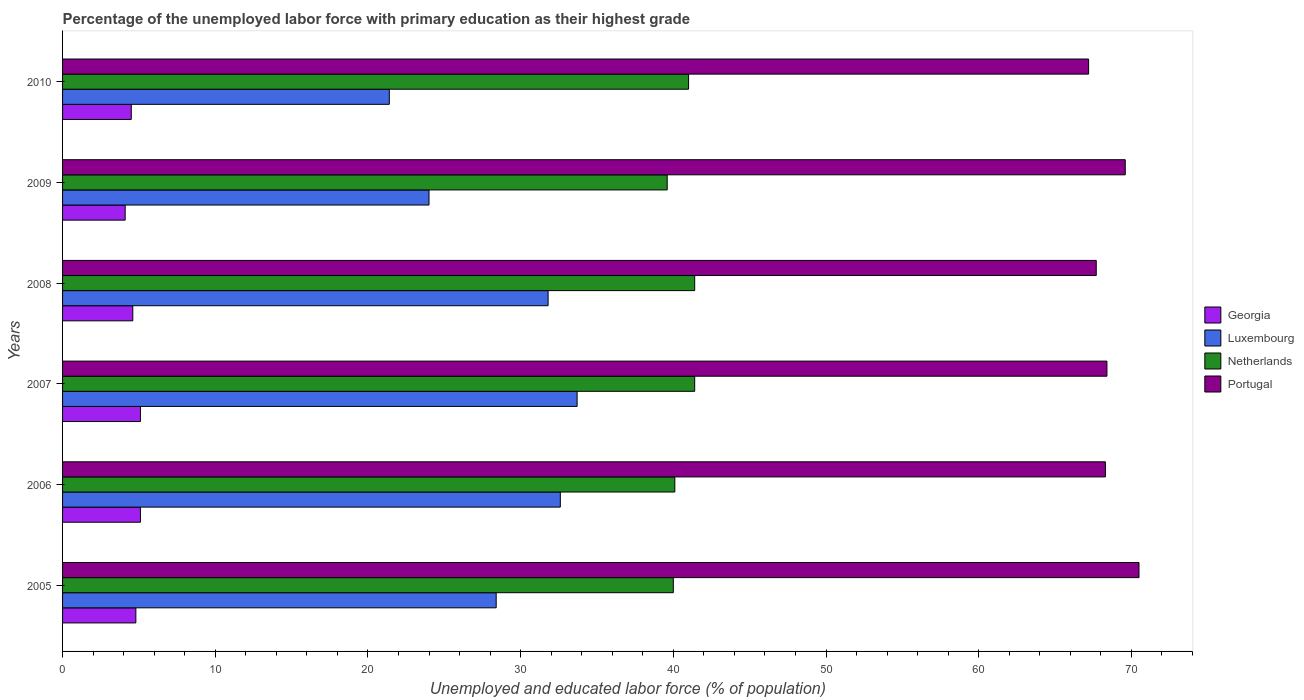Are the number of bars per tick equal to the number of legend labels?
Ensure brevity in your answer.  Yes. In how many cases, is the number of bars for a given year not equal to the number of legend labels?
Ensure brevity in your answer.  0. What is the percentage of the unemployed labor force with primary education in Georgia in 2008?
Your response must be concise. 4.6. Across all years, what is the maximum percentage of the unemployed labor force with primary education in Georgia?
Keep it short and to the point. 5.1. Across all years, what is the minimum percentage of the unemployed labor force with primary education in Portugal?
Your response must be concise. 67.2. In which year was the percentage of the unemployed labor force with primary education in Georgia minimum?
Keep it short and to the point. 2009. What is the total percentage of the unemployed labor force with primary education in Netherlands in the graph?
Offer a very short reply. 243.5. What is the difference between the percentage of the unemployed labor force with primary education in Georgia in 2006 and that in 2010?
Offer a very short reply. 0.6. What is the difference between the percentage of the unemployed labor force with primary education in Luxembourg in 2005 and the percentage of the unemployed labor force with primary education in Netherlands in 2007?
Offer a very short reply. -13. What is the average percentage of the unemployed labor force with primary education in Portugal per year?
Make the answer very short. 68.62. In the year 2005, what is the difference between the percentage of the unemployed labor force with primary education in Luxembourg and percentage of the unemployed labor force with primary education in Netherlands?
Your response must be concise. -11.6. In how many years, is the percentage of the unemployed labor force with primary education in Georgia greater than 48 %?
Provide a short and direct response. 0. What is the ratio of the percentage of the unemployed labor force with primary education in Netherlands in 2006 to that in 2007?
Your answer should be very brief. 0.97. Is the percentage of the unemployed labor force with primary education in Georgia in 2006 less than that in 2009?
Your response must be concise. No. What is the difference between the highest and the second highest percentage of the unemployed labor force with primary education in Luxembourg?
Your response must be concise. 1.1. What is the difference between the highest and the lowest percentage of the unemployed labor force with primary education in Portugal?
Ensure brevity in your answer.  3.3. In how many years, is the percentage of the unemployed labor force with primary education in Portugal greater than the average percentage of the unemployed labor force with primary education in Portugal taken over all years?
Keep it short and to the point. 2. Is the sum of the percentage of the unemployed labor force with primary education in Luxembourg in 2006 and 2009 greater than the maximum percentage of the unemployed labor force with primary education in Netherlands across all years?
Offer a very short reply. Yes. What does the 4th bar from the top in 2009 represents?
Offer a very short reply. Georgia. What does the 3rd bar from the bottom in 2009 represents?
Keep it short and to the point. Netherlands. Is it the case that in every year, the sum of the percentage of the unemployed labor force with primary education in Luxembourg and percentage of the unemployed labor force with primary education in Portugal is greater than the percentage of the unemployed labor force with primary education in Georgia?
Make the answer very short. Yes. How many bars are there?
Keep it short and to the point. 24. How many years are there in the graph?
Give a very brief answer. 6. What is the difference between two consecutive major ticks on the X-axis?
Provide a short and direct response. 10. Are the values on the major ticks of X-axis written in scientific E-notation?
Offer a very short reply. No. Does the graph contain any zero values?
Give a very brief answer. No. Where does the legend appear in the graph?
Make the answer very short. Center right. How many legend labels are there?
Your answer should be very brief. 4. How are the legend labels stacked?
Your answer should be compact. Vertical. What is the title of the graph?
Offer a very short reply. Percentage of the unemployed labor force with primary education as their highest grade. What is the label or title of the X-axis?
Provide a succinct answer. Unemployed and educated labor force (% of population). What is the label or title of the Y-axis?
Ensure brevity in your answer.  Years. What is the Unemployed and educated labor force (% of population) in Georgia in 2005?
Offer a very short reply. 4.8. What is the Unemployed and educated labor force (% of population) of Luxembourg in 2005?
Make the answer very short. 28.4. What is the Unemployed and educated labor force (% of population) of Netherlands in 2005?
Ensure brevity in your answer.  40. What is the Unemployed and educated labor force (% of population) of Portugal in 2005?
Ensure brevity in your answer.  70.5. What is the Unemployed and educated labor force (% of population) of Georgia in 2006?
Your answer should be compact. 5.1. What is the Unemployed and educated labor force (% of population) of Luxembourg in 2006?
Provide a short and direct response. 32.6. What is the Unemployed and educated labor force (% of population) of Netherlands in 2006?
Offer a very short reply. 40.1. What is the Unemployed and educated labor force (% of population) of Portugal in 2006?
Keep it short and to the point. 68.3. What is the Unemployed and educated labor force (% of population) in Georgia in 2007?
Provide a succinct answer. 5.1. What is the Unemployed and educated labor force (% of population) of Luxembourg in 2007?
Your response must be concise. 33.7. What is the Unemployed and educated labor force (% of population) of Netherlands in 2007?
Provide a succinct answer. 41.4. What is the Unemployed and educated labor force (% of population) in Portugal in 2007?
Make the answer very short. 68.4. What is the Unemployed and educated labor force (% of population) of Georgia in 2008?
Your answer should be compact. 4.6. What is the Unemployed and educated labor force (% of population) of Luxembourg in 2008?
Give a very brief answer. 31.8. What is the Unemployed and educated labor force (% of population) of Netherlands in 2008?
Provide a short and direct response. 41.4. What is the Unemployed and educated labor force (% of population) in Portugal in 2008?
Your answer should be compact. 67.7. What is the Unemployed and educated labor force (% of population) in Georgia in 2009?
Ensure brevity in your answer.  4.1. What is the Unemployed and educated labor force (% of population) of Luxembourg in 2009?
Provide a short and direct response. 24. What is the Unemployed and educated labor force (% of population) of Netherlands in 2009?
Offer a very short reply. 39.6. What is the Unemployed and educated labor force (% of population) in Portugal in 2009?
Provide a succinct answer. 69.6. What is the Unemployed and educated labor force (% of population) in Luxembourg in 2010?
Keep it short and to the point. 21.4. What is the Unemployed and educated labor force (% of population) of Portugal in 2010?
Provide a succinct answer. 67.2. Across all years, what is the maximum Unemployed and educated labor force (% of population) in Georgia?
Keep it short and to the point. 5.1. Across all years, what is the maximum Unemployed and educated labor force (% of population) in Luxembourg?
Offer a terse response. 33.7. Across all years, what is the maximum Unemployed and educated labor force (% of population) of Netherlands?
Provide a succinct answer. 41.4. Across all years, what is the maximum Unemployed and educated labor force (% of population) of Portugal?
Offer a very short reply. 70.5. Across all years, what is the minimum Unemployed and educated labor force (% of population) of Georgia?
Your response must be concise. 4.1. Across all years, what is the minimum Unemployed and educated labor force (% of population) of Luxembourg?
Ensure brevity in your answer.  21.4. Across all years, what is the minimum Unemployed and educated labor force (% of population) in Netherlands?
Provide a short and direct response. 39.6. Across all years, what is the minimum Unemployed and educated labor force (% of population) of Portugal?
Give a very brief answer. 67.2. What is the total Unemployed and educated labor force (% of population) in Georgia in the graph?
Your response must be concise. 28.2. What is the total Unemployed and educated labor force (% of population) of Luxembourg in the graph?
Provide a succinct answer. 171.9. What is the total Unemployed and educated labor force (% of population) in Netherlands in the graph?
Give a very brief answer. 243.5. What is the total Unemployed and educated labor force (% of population) of Portugal in the graph?
Provide a succinct answer. 411.7. What is the difference between the Unemployed and educated labor force (% of population) in Netherlands in 2005 and that in 2006?
Your answer should be compact. -0.1. What is the difference between the Unemployed and educated labor force (% of population) of Georgia in 2005 and that in 2007?
Your response must be concise. -0.3. What is the difference between the Unemployed and educated labor force (% of population) in Luxembourg in 2005 and that in 2007?
Keep it short and to the point. -5.3. What is the difference between the Unemployed and educated labor force (% of population) of Netherlands in 2005 and that in 2007?
Make the answer very short. -1.4. What is the difference between the Unemployed and educated labor force (% of population) of Netherlands in 2005 and that in 2008?
Make the answer very short. -1.4. What is the difference between the Unemployed and educated labor force (% of population) of Portugal in 2005 and that in 2008?
Your answer should be very brief. 2.8. What is the difference between the Unemployed and educated labor force (% of population) in Georgia in 2005 and that in 2009?
Keep it short and to the point. 0.7. What is the difference between the Unemployed and educated labor force (% of population) of Georgia in 2005 and that in 2010?
Provide a short and direct response. 0.3. What is the difference between the Unemployed and educated labor force (% of population) in Netherlands in 2005 and that in 2010?
Give a very brief answer. -1. What is the difference between the Unemployed and educated labor force (% of population) of Portugal in 2005 and that in 2010?
Your answer should be compact. 3.3. What is the difference between the Unemployed and educated labor force (% of population) of Netherlands in 2006 and that in 2007?
Your answer should be very brief. -1.3. What is the difference between the Unemployed and educated labor force (% of population) in Portugal in 2006 and that in 2007?
Ensure brevity in your answer.  -0.1. What is the difference between the Unemployed and educated labor force (% of population) in Georgia in 2006 and that in 2008?
Your answer should be compact. 0.5. What is the difference between the Unemployed and educated labor force (% of population) in Luxembourg in 2006 and that in 2008?
Provide a succinct answer. 0.8. What is the difference between the Unemployed and educated labor force (% of population) in Netherlands in 2006 and that in 2008?
Provide a succinct answer. -1.3. What is the difference between the Unemployed and educated labor force (% of population) of Portugal in 2006 and that in 2008?
Provide a succinct answer. 0.6. What is the difference between the Unemployed and educated labor force (% of population) in Luxembourg in 2006 and that in 2009?
Give a very brief answer. 8.6. What is the difference between the Unemployed and educated labor force (% of population) in Portugal in 2006 and that in 2009?
Provide a short and direct response. -1.3. What is the difference between the Unemployed and educated labor force (% of population) in Georgia in 2006 and that in 2010?
Give a very brief answer. 0.6. What is the difference between the Unemployed and educated labor force (% of population) of Luxembourg in 2006 and that in 2010?
Your response must be concise. 11.2. What is the difference between the Unemployed and educated labor force (% of population) in Netherlands in 2006 and that in 2010?
Provide a succinct answer. -0.9. What is the difference between the Unemployed and educated labor force (% of population) in Portugal in 2006 and that in 2010?
Make the answer very short. 1.1. What is the difference between the Unemployed and educated labor force (% of population) of Georgia in 2007 and that in 2008?
Provide a succinct answer. 0.5. What is the difference between the Unemployed and educated labor force (% of population) of Luxembourg in 2007 and that in 2008?
Offer a very short reply. 1.9. What is the difference between the Unemployed and educated labor force (% of population) in Portugal in 2007 and that in 2008?
Your answer should be very brief. 0.7. What is the difference between the Unemployed and educated labor force (% of population) in Georgia in 2007 and that in 2009?
Your answer should be very brief. 1. What is the difference between the Unemployed and educated labor force (% of population) in Luxembourg in 2007 and that in 2009?
Make the answer very short. 9.7. What is the difference between the Unemployed and educated labor force (% of population) in Netherlands in 2007 and that in 2009?
Make the answer very short. 1.8. What is the difference between the Unemployed and educated labor force (% of population) of Portugal in 2007 and that in 2009?
Provide a short and direct response. -1.2. What is the difference between the Unemployed and educated labor force (% of population) of Georgia in 2007 and that in 2010?
Your answer should be compact. 0.6. What is the difference between the Unemployed and educated labor force (% of population) of Georgia in 2008 and that in 2009?
Ensure brevity in your answer.  0.5. What is the difference between the Unemployed and educated labor force (% of population) in Netherlands in 2008 and that in 2009?
Your response must be concise. 1.8. What is the difference between the Unemployed and educated labor force (% of population) in Portugal in 2008 and that in 2009?
Offer a terse response. -1.9. What is the difference between the Unemployed and educated labor force (% of population) in Luxembourg in 2008 and that in 2010?
Make the answer very short. 10.4. What is the difference between the Unemployed and educated labor force (% of population) in Netherlands in 2008 and that in 2010?
Make the answer very short. 0.4. What is the difference between the Unemployed and educated labor force (% of population) of Georgia in 2009 and that in 2010?
Offer a very short reply. -0.4. What is the difference between the Unemployed and educated labor force (% of population) in Luxembourg in 2009 and that in 2010?
Make the answer very short. 2.6. What is the difference between the Unemployed and educated labor force (% of population) in Georgia in 2005 and the Unemployed and educated labor force (% of population) in Luxembourg in 2006?
Your answer should be compact. -27.8. What is the difference between the Unemployed and educated labor force (% of population) of Georgia in 2005 and the Unemployed and educated labor force (% of population) of Netherlands in 2006?
Ensure brevity in your answer.  -35.3. What is the difference between the Unemployed and educated labor force (% of population) in Georgia in 2005 and the Unemployed and educated labor force (% of population) in Portugal in 2006?
Keep it short and to the point. -63.5. What is the difference between the Unemployed and educated labor force (% of population) in Luxembourg in 2005 and the Unemployed and educated labor force (% of population) in Portugal in 2006?
Provide a succinct answer. -39.9. What is the difference between the Unemployed and educated labor force (% of population) of Netherlands in 2005 and the Unemployed and educated labor force (% of population) of Portugal in 2006?
Provide a short and direct response. -28.3. What is the difference between the Unemployed and educated labor force (% of population) in Georgia in 2005 and the Unemployed and educated labor force (% of population) in Luxembourg in 2007?
Ensure brevity in your answer.  -28.9. What is the difference between the Unemployed and educated labor force (% of population) of Georgia in 2005 and the Unemployed and educated labor force (% of population) of Netherlands in 2007?
Your response must be concise. -36.6. What is the difference between the Unemployed and educated labor force (% of population) of Georgia in 2005 and the Unemployed and educated labor force (% of population) of Portugal in 2007?
Keep it short and to the point. -63.6. What is the difference between the Unemployed and educated labor force (% of population) in Luxembourg in 2005 and the Unemployed and educated labor force (% of population) in Netherlands in 2007?
Provide a succinct answer. -13. What is the difference between the Unemployed and educated labor force (% of population) of Netherlands in 2005 and the Unemployed and educated labor force (% of population) of Portugal in 2007?
Make the answer very short. -28.4. What is the difference between the Unemployed and educated labor force (% of population) of Georgia in 2005 and the Unemployed and educated labor force (% of population) of Luxembourg in 2008?
Ensure brevity in your answer.  -27. What is the difference between the Unemployed and educated labor force (% of population) in Georgia in 2005 and the Unemployed and educated labor force (% of population) in Netherlands in 2008?
Provide a short and direct response. -36.6. What is the difference between the Unemployed and educated labor force (% of population) of Georgia in 2005 and the Unemployed and educated labor force (% of population) of Portugal in 2008?
Offer a terse response. -62.9. What is the difference between the Unemployed and educated labor force (% of population) in Luxembourg in 2005 and the Unemployed and educated labor force (% of population) in Netherlands in 2008?
Give a very brief answer. -13. What is the difference between the Unemployed and educated labor force (% of population) of Luxembourg in 2005 and the Unemployed and educated labor force (% of population) of Portugal in 2008?
Make the answer very short. -39.3. What is the difference between the Unemployed and educated labor force (% of population) of Netherlands in 2005 and the Unemployed and educated labor force (% of population) of Portugal in 2008?
Your response must be concise. -27.7. What is the difference between the Unemployed and educated labor force (% of population) of Georgia in 2005 and the Unemployed and educated labor force (% of population) of Luxembourg in 2009?
Keep it short and to the point. -19.2. What is the difference between the Unemployed and educated labor force (% of population) in Georgia in 2005 and the Unemployed and educated labor force (% of population) in Netherlands in 2009?
Give a very brief answer. -34.8. What is the difference between the Unemployed and educated labor force (% of population) of Georgia in 2005 and the Unemployed and educated labor force (% of population) of Portugal in 2009?
Provide a short and direct response. -64.8. What is the difference between the Unemployed and educated labor force (% of population) of Luxembourg in 2005 and the Unemployed and educated labor force (% of population) of Netherlands in 2009?
Offer a very short reply. -11.2. What is the difference between the Unemployed and educated labor force (% of population) in Luxembourg in 2005 and the Unemployed and educated labor force (% of population) in Portugal in 2009?
Provide a short and direct response. -41.2. What is the difference between the Unemployed and educated labor force (% of population) of Netherlands in 2005 and the Unemployed and educated labor force (% of population) of Portugal in 2009?
Offer a very short reply. -29.6. What is the difference between the Unemployed and educated labor force (% of population) in Georgia in 2005 and the Unemployed and educated labor force (% of population) in Luxembourg in 2010?
Your response must be concise. -16.6. What is the difference between the Unemployed and educated labor force (% of population) in Georgia in 2005 and the Unemployed and educated labor force (% of population) in Netherlands in 2010?
Provide a succinct answer. -36.2. What is the difference between the Unemployed and educated labor force (% of population) in Georgia in 2005 and the Unemployed and educated labor force (% of population) in Portugal in 2010?
Offer a very short reply. -62.4. What is the difference between the Unemployed and educated labor force (% of population) of Luxembourg in 2005 and the Unemployed and educated labor force (% of population) of Netherlands in 2010?
Offer a very short reply. -12.6. What is the difference between the Unemployed and educated labor force (% of population) in Luxembourg in 2005 and the Unemployed and educated labor force (% of population) in Portugal in 2010?
Provide a succinct answer. -38.8. What is the difference between the Unemployed and educated labor force (% of population) in Netherlands in 2005 and the Unemployed and educated labor force (% of population) in Portugal in 2010?
Offer a very short reply. -27.2. What is the difference between the Unemployed and educated labor force (% of population) of Georgia in 2006 and the Unemployed and educated labor force (% of population) of Luxembourg in 2007?
Keep it short and to the point. -28.6. What is the difference between the Unemployed and educated labor force (% of population) in Georgia in 2006 and the Unemployed and educated labor force (% of population) in Netherlands in 2007?
Give a very brief answer. -36.3. What is the difference between the Unemployed and educated labor force (% of population) of Georgia in 2006 and the Unemployed and educated labor force (% of population) of Portugal in 2007?
Your answer should be compact. -63.3. What is the difference between the Unemployed and educated labor force (% of population) of Luxembourg in 2006 and the Unemployed and educated labor force (% of population) of Portugal in 2007?
Offer a terse response. -35.8. What is the difference between the Unemployed and educated labor force (% of population) of Netherlands in 2006 and the Unemployed and educated labor force (% of population) of Portugal in 2007?
Offer a terse response. -28.3. What is the difference between the Unemployed and educated labor force (% of population) in Georgia in 2006 and the Unemployed and educated labor force (% of population) in Luxembourg in 2008?
Offer a terse response. -26.7. What is the difference between the Unemployed and educated labor force (% of population) of Georgia in 2006 and the Unemployed and educated labor force (% of population) of Netherlands in 2008?
Make the answer very short. -36.3. What is the difference between the Unemployed and educated labor force (% of population) in Georgia in 2006 and the Unemployed and educated labor force (% of population) in Portugal in 2008?
Provide a short and direct response. -62.6. What is the difference between the Unemployed and educated labor force (% of population) of Luxembourg in 2006 and the Unemployed and educated labor force (% of population) of Netherlands in 2008?
Your response must be concise. -8.8. What is the difference between the Unemployed and educated labor force (% of population) in Luxembourg in 2006 and the Unemployed and educated labor force (% of population) in Portugal in 2008?
Your answer should be compact. -35.1. What is the difference between the Unemployed and educated labor force (% of population) in Netherlands in 2006 and the Unemployed and educated labor force (% of population) in Portugal in 2008?
Provide a succinct answer. -27.6. What is the difference between the Unemployed and educated labor force (% of population) of Georgia in 2006 and the Unemployed and educated labor force (% of population) of Luxembourg in 2009?
Your answer should be compact. -18.9. What is the difference between the Unemployed and educated labor force (% of population) in Georgia in 2006 and the Unemployed and educated labor force (% of population) in Netherlands in 2009?
Offer a terse response. -34.5. What is the difference between the Unemployed and educated labor force (% of population) in Georgia in 2006 and the Unemployed and educated labor force (% of population) in Portugal in 2009?
Provide a short and direct response. -64.5. What is the difference between the Unemployed and educated labor force (% of population) in Luxembourg in 2006 and the Unemployed and educated labor force (% of population) in Portugal in 2009?
Your response must be concise. -37. What is the difference between the Unemployed and educated labor force (% of population) of Netherlands in 2006 and the Unemployed and educated labor force (% of population) of Portugal in 2009?
Make the answer very short. -29.5. What is the difference between the Unemployed and educated labor force (% of population) in Georgia in 2006 and the Unemployed and educated labor force (% of population) in Luxembourg in 2010?
Make the answer very short. -16.3. What is the difference between the Unemployed and educated labor force (% of population) in Georgia in 2006 and the Unemployed and educated labor force (% of population) in Netherlands in 2010?
Make the answer very short. -35.9. What is the difference between the Unemployed and educated labor force (% of population) of Georgia in 2006 and the Unemployed and educated labor force (% of population) of Portugal in 2010?
Ensure brevity in your answer.  -62.1. What is the difference between the Unemployed and educated labor force (% of population) of Luxembourg in 2006 and the Unemployed and educated labor force (% of population) of Netherlands in 2010?
Keep it short and to the point. -8.4. What is the difference between the Unemployed and educated labor force (% of population) in Luxembourg in 2006 and the Unemployed and educated labor force (% of population) in Portugal in 2010?
Offer a terse response. -34.6. What is the difference between the Unemployed and educated labor force (% of population) in Netherlands in 2006 and the Unemployed and educated labor force (% of population) in Portugal in 2010?
Make the answer very short. -27.1. What is the difference between the Unemployed and educated labor force (% of population) of Georgia in 2007 and the Unemployed and educated labor force (% of population) of Luxembourg in 2008?
Ensure brevity in your answer.  -26.7. What is the difference between the Unemployed and educated labor force (% of population) of Georgia in 2007 and the Unemployed and educated labor force (% of population) of Netherlands in 2008?
Provide a short and direct response. -36.3. What is the difference between the Unemployed and educated labor force (% of population) in Georgia in 2007 and the Unemployed and educated labor force (% of population) in Portugal in 2008?
Your answer should be compact. -62.6. What is the difference between the Unemployed and educated labor force (% of population) of Luxembourg in 2007 and the Unemployed and educated labor force (% of population) of Portugal in 2008?
Give a very brief answer. -34. What is the difference between the Unemployed and educated labor force (% of population) of Netherlands in 2007 and the Unemployed and educated labor force (% of population) of Portugal in 2008?
Your answer should be compact. -26.3. What is the difference between the Unemployed and educated labor force (% of population) in Georgia in 2007 and the Unemployed and educated labor force (% of population) in Luxembourg in 2009?
Your response must be concise. -18.9. What is the difference between the Unemployed and educated labor force (% of population) in Georgia in 2007 and the Unemployed and educated labor force (% of population) in Netherlands in 2009?
Give a very brief answer. -34.5. What is the difference between the Unemployed and educated labor force (% of population) in Georgia in 2007 and the Unemployed and educated labor force (% of population) in Portugal in 2009?
Provide a short and direct response. -64.5. What is the difference between the Unemployed and educated labor force (% of population) of Luxembourg in 2007 and the Unemployed and educated labor force (% of population) of Netherlands in 2009?
Your response must be concise. -5.9. What is the difference between the Unemployed and educated labor force (% of population) of Luxembourg in 2007 and the Unemployed and educated labor force (% of population) of Portugal in 2009?
Keep it short and to the point. -35.9. What is the difference between the Unemployed and educated labor force (% of population) in Netherlands in 2007 and the Unemployed and educated labor force (% of population) in Portugal in 2009?
Give a very brief answer. -28.2. What is the difference between the Unemployed and educated labor force (% of population) of Georgia in 2007 and the Unemployed and educated labor force (% of population) of Luxembourg in 2010?
Offer a very short reply. -16.3. What is the difference between the Unemployed and educated labor force (% of population) in Georgia in 2007 and the Unemployed and educated labor force (% of population) in Netherlands in 2010?
Give a very brief answer. -35.9. What is the difference between the Unemployed and educated labor force (% of population) in Georgia in 2007 and the Unemployed and educated labor force (% of population) in Portugal in 2010?
Your response must be concise. -62.1. What is the difference between the Unemployed and educated labor force (% of population) of Luxembourg in 2007 and the Unemployed and educated labor force (% of population) of Portugal in 2010?
Ensure brevity in your answer.  -33.5. What is the difference between the Unemployed and educated labor force (% of population) of Netherlands in 2007 and the Unemployed and educated labor force (% of population) of Portugal in 2010?
Offer a very short reply. -25.8. What is the difference between the Unemployed and educated labor force (% of population) in Georgia in 2008 and the Unemployed and educated labor force (% of population) in Luxembourg in 2009?
Ensure brevity in your answer.  -19.4. What is the difference between the Unemployed and educated labor force (% of population) of Georgia in 2008 and the Unemployed and educated labor force (% of population) of Netherlands in 2009?
Make the answer very short. -35. What is the difference between the Unemployed and educated labor force (% of population) of Georgia in 2008 and the Unemployed and educated labor force (% of population) of Portugal in 2009?
Make the answer very short. -65. What is the difference between the Unemployed and educated labor force (% of population) of Luxembourg in 2008 and the Unemployed and educated labor force (% of population) of Netherlands in 2009?
Make the answer very short. -7.8. What is the difference between the Unemployed and educated labor force (% of population) in Luxembourg in 2008 and the Unemployed and educated labor force (% of population) in Portugal in 2009?
Ensure brevity in your answer.  -37.8. What is the difference between the Unemployed and educated labor force (% of population) of Netherlands in 2008 and the Unemployed and educated labor force (% of population) of Portugal in 2009?
Your response must be concise. -28.2. What is the difference between the Unemployed and educated labor force (% of population) of Georgia in 2008 and the Unemployed and educated labor force (% of population) of Luxembourg in 2010?
Give a very brief answer. -16.8. What is the difference between the Unemployed and educated labor force (% of population) of Georgia in 2008 and the Unemployed and educated labor force (% of population) of Netherlands in 2010?
Provide a succinct answer. -36.4. What is the difference between the Unemployed and educated labor force (% of population) of Georgia in 2008 and the Unemployed and educated labor force (% of population) of Portugal in 2010?
Offer a very short reply. -62.6. What is the difference between the Unemployed and educated labor force (% of population) in Luxembourg in 2008 and the Unemployed and educated labor force (% of population) in Netherlands in 2010?
Offer a very short reply. -9.2. What is the difference between the Unemployed and educated labor force (% of population) of Luxembourg in 2008 and the Unemployed and educated labor force (% of population) of Portugal in 2010?
Provide a succinct answer. -35.4. What is the difference between the Unemployed and educated labor force (% of population) of Netherlands in 2008 and the Unemployed and educated labor force (% of population) of Portugal in 2010?
Your answer should be very brief. -25.8. What is the difference between the Unemployed and educated labor force (% of population) of Georgia in 2009 and the Unemployed and educated labor force (% of population) of Luxembourg in 2010?
Your answer should be compact. -17.3. What is the difference between the Unemployed and educated labor force (% of population) of Georgia in 2009 and the Unemployed and educated labor force (% of population) of Netherlands in 2010?
Make the answer very short. -36.9. What is the difference between the Unemployed and educated labor force (% of population) in Georgia in 2009 and the Unemployed and educated labor force (% of population) in Portugal in 2010?
Keep it short and to the point. -63.1. What is the difference between the Unemployed and educated labor force (% of population) of Luxembourg in 2009 and the Unemployed and educated labor force (% of population) of Netherlands in 2010?
Make the answer very short. -17. What is the difference between the Unemployed and educated labor force (% of population) of Luxembourg in 2009 and the Unemployed and educated labor force (% of population) of Portugal in 2010?
Provide a succinct answer. -43.2. What is the difference between the Unemployed and educated labor force (% of population) of Netherlands in 2009 and the Unemployed and educated labor force (% of population) of Portugal in 2010?
Your answer should be compact. -27.6. What is the average Unemployed and educated labor force (% of population) of Georgia per year?
Keep it short and to the point. 4.7. What is the average Unemployed and educated labor force (% of population) of Luxembourg per year?
Your response must be concise. 28.65. What is the average Unemployed and educated labor force (% of population) of Netherlands per year?
Offer a terse response. 40.58. What is the average Unemployed and educated labor force (% of population) of Portugal per year?
Give a very brief answer. 68.62. In the year 2005, what is the difference between the Unemployed and educated labor force (% of population) in Georgia and Unemployed and educated labor force (% of population) in Luxembourg?
Your answer should be compact. -23.6. In the year 2005, what is the difference between the Unemployed and educated labor force (% of population) of Georgia and Unemployed and educated labor force (% of population) of Netherlands?
Ensure brevity in your answer.  -35.2. In the year 2005, what is the difference between the Unemployed and educated labor force (% of population) in Georgia and Unemployed and educated labor force (% of population) in Portugal?
Offer a very short reply. -65.7. In the year 2005, what is the difference between the Unemployed and educated labor force (% of population) in Luxembourg and Unemployed and educated labor force (% of population) in Portugal?
Your answer should be very brief. -42.1. In the year 2005, what is the difference between the Unemployed and educated labor force (% of population) of Netherlands and Unemployed and educated labor force (% of population) of Portugal?
Provide a short and direct response. -30.5. In the year 2006, what is the difference between the Unemployed and educated labor force (% of population) in Georgia and Unemployed and educated labor force (% of population) in Luxembourg?
Offer a terse response. -27.5. In the year 2006, what is the difference between the Unemployed and educated labor force (% of population) in Georgia and Unemployed and educated labor force (% of population) in Netherlands?
Give a very brief answer. -35. In the year 2006, what is the difference between the Unemployed and educated labor force (% of population) in Georgia and Unemployed and educated labor force (% of population) in Portugal?
Ensure brevity in your answer.  -63.2. In the year 2006, what is the difference between the Unemployed and educated labor force (% of population) of Luxembourg and Unemployed and educated labor force (% of population) of Netherlands?
Provide a short and direct response. -7.5. In the year 2006, what is the difference between the Unemployed and educated labor force (% of population) of Luxembourg and Unemployed and educated labor force (% of population) of Portugal?
Your answer should be very brief. -35.7. In the year 2006, what is the difference between the Unemployed and educated labor force (% of population) of Netherlands and Unemployed and educated labor force (% of population) of Portugal?
Make the answer very short. -28.2. In the year 2007, what is the difference between the Unemployed and educated labor force (% of population) of Georgia and Unemployed and educated labor force (% of population) of Luxembourg?
Your answer should be compact. -28.6. In the year 2007, what is the difference between the Unemployed and educated labor force (% of population) of Georgia and Unemployed and educated labor force (% of population) of Netherlands?
Provide a short and direct response. -36.3. In the year 2007, what is the difference between the Unemployed and educated labor force (% of population) of Georgia and Unemployed and educated labor force (% of population) of Portugal?
Give a very brief answer. -63.3. In the year 2007, what is the difference between the Unemployed and educated labor force (% of population) in Luxembourg and Unemployed and educated labor force (% of population) in Portugal?
Your response must be concise. -34.7. In the year 2008, what is the difference between the Unemployed and educated labor force (% of population) of Georgia and Unemployed and educated labor force (% of population) of Luxembourg?
Your response must be concise. -27.2. In the year 2008, what is the difference between the Unemployed and educated labor force (% of population) of Georgia and Unemployed and educated labor force (% of population) of Netherlands?
Offer a terse response. -36.8. In the year 2008, what is the difference between the Unemployed and educated labor force (% of population) in Georgia and Unemployed and educated labor force (% of population) in Portugal?
Ensure brevity in your answer.  -63.1. In the year 2008, what is the difference between the Unemployed and educated labor force (% of population) in Luxembourg and Unemployed and educated labor force (% of population) in Netherlands?
Offer a terse response. -9.6. In the year 2008, what is the difference between the Unemployed and educated labor force (% of population) of Luxembourg and Unemployed and educated labor force (% of population) of Portugal?
Your answer should be very brief. -35.9. In the year 2008, what is the difference between the Unemployed and educated labor force (% of population) of Netherlands and Unemployed and educated labor force (% of population) of Portugal?
Provide a succinct answer. -26.3. In the year 2009, what is the difference between the Unemployed and educated labor force (% of population) of Georgia and Unemployed and educated labor force (% of population) of Luxembourg?
Give a very brief answer. -19.9. In the year 2009, what is the difference between the Unemployed and educated labor force (% of population) of Georgia and Unemployed and educated labor force (% of population) of Netherlands?
Offer a very short reply. -35.5. In the year 2009, what is the difference between the Unemployed and educated labor force (% of population) of Georgia and Unemployed and educated labor force (% of population) of Portugal?
Keep it short and to the point. -65.5. In the year 2009, what is the difference between the Unemployed and educated labor force (% of population) in Luxembourg and Unemployed and educated labor force (% of population) in Netherlands?
Give a very brief answer. -15.6. In the year 2009, what is the difference between the Unemployed and educated labor force (% of population) in Luxembourg and Unemployed and educated labor force (% of population) in Portugal?
Your response must be concise. -45.6. In the year 2010, what is the difference between the Unemployed and educated labor force (% of population) of Georgia and Unemployed and educated labor force (% of population) of Luxembourg?
Your response must be concise. -16.9. In the year 2010, what is the difference between the Unemployed and educated labor force (% of population) in Georgia and Unemployed and educated labor force (% of population) in Netherlands?
Your answer should be very brief. -36.5. In the year 2010, what is the difference between the Unemployed and educated labor force (% of population) in Georgia and Unemployed and educated labor force (% of population) in Portugal?
Keep it short and to the point. -62.7. In the year 2010, what is the difference between the Unemployed and educated labor force (% of population) in Luxembourg and Unemployed and educated labor force (% of population) in Netherlands?
Provide a short and direct response. -19.6. In the year 2010, what is the difference between the Unemployed and educated labor force (% of population) of Luxembourg and Unemployed and educated labor force (% of population) of Portugal?
Ensure brevity in your answer.  -45.8. In the year 2010, what is the difference between the Unemployed and educated labor force (% of population) of Netherlands and Unemployed and educated labor force (% of population) of Portugal?
Make the answer very short. -26.2. What is the ratio of the Unemployed and educated labor force (% of population) of Luxembourg in 2005 to that in 2006?
Your answer should be compact. 0.87. What is the ratio of the Unemployed and educated labor force (% of population) in Portugal in 2005 to that in 2006?
Make the answer very short. 1.03. What is the ratio of the Unemployed and educated labor force (% of population) in Georgia in 2005 to that in 2007?
Your answer should be very brief. 0.94. What is the ratio of the Unemployed and educated labor force (% of population) in Luxembourg in 2005 to that in 2007?
Make the answer very short. 0.84. What is the ratio of the Unemployed and educated labor force (% of population) in Netherlands in 2005 to that in 2007?
Give a very brief answer. 0.97. What is the ratio of the Unemployed and educated labor force (% of population) of Portugal in 2005 to that in 2007?
Your answer should be very brief. 1.03. What is the ratio of the Unemployed and educated labor force (% of population) of Georgia in 2005 to that in 2008?
Your answer should be compact. 1.04. What is the ratio of the Unemployed and educated labor force (% of population) in Luxembourg in 2005 to that in 2008?
Ensure brevity in your answer.  0.89. What is the ratio of the Unemployed and educated labor force (% of population) of Netherlands in 2005 to that in 2008?
Your answer should be compact. 0.97. What is the ratio of the Unemployed and educated labor force (% of population) in Portugal in 2005 to that in 2008?
Offer a very short reply. 1.04. What is the ratio of the Unemployed and educated labor force (% of population) of Georgia in 2005 to that in 2009?
Your response must be concise. 1.17. What is the ratio of the Unemployed and educated labor force (% of population) of Luxembourg in 2005 to that in 2009?
Keep it short and to the point. 1.18. What is the ratio of the Unemployed and educated labor force (% of population) of Netherlands in 2005 to that in 2009?
Your answer should be compact. 1.01. What is the ratio of the Unemployed and educated labor force (% of population) in Portugal in 2005 to that in 2009?
Make the answer very short. 1.01. What is the ratio of the Unemployed and educated labor force (% of population) in Georgia in 2005 to that in 2010?
Provide a short and direct response. 1.07. What is the ratio of the Unemployed and educated labor force (% of population) in Luxembourg in 2005 to that in 2010?
Ensure brevity in your answer.  1.33. What is the ratio of the Unemployed and educated labor force (% of population) of Netherlands in 2005 to that in 2010?
Offer a very short reply. 0.98. What is the ratio of the Unemployed and educated labor force (% of population) in Portugal in 2005 to that in 2010?
Keep it short and to the point. 1.05. What is the ratio of the Unemployed and educated labor force (% of population) of Georgia in 2006 to that in 2007?
Ensure brevity in your answer.  1. What is the ratio of the Unemployed and educated labor force (% of population) in Luxembourg in 2006 to that in 2007?
Offer a very short reply. 0.97. What is the ratio of the Unemployed and educated labor force (% of population) of Netherlands in 2006 to that in 2007?
Make the answer very short. 0.97. What is the ratio of the Unemployed and educated labor force (% of population) in Portugal in 2006 to that in 2007?
Provide a short and direct response. 1. What is the ratio of the Unemployed and educated labor force (% of population) in Georgia in 2006 to that in 2008?
Give a very brief answer. 1.11. What is the ratio of the Unemployed and educated labor force (% of population) in Luxembourg in 2006 to that in 2008?
Keep it short and to the point. 1.03. What is the ratio of the Unemployed and educated labor force (% of population) of Netherlands in 2006 to that in 2008?
Ensure brevity in your answer.  0.97. What is the ratio of the Unemployed and educated labor force (% of population) of Portugal in 2006 to that in 2008?
Ensure brevity in your answer.  1.01. What is the ratio of the Unemployed and educated labor force (% of population) of Georgia in 2006 to that in 2009?
Your answer should be compact. 1.24. What is the ratio of the Unemployed and educated labor force (% of population) of Luxembourg in 2006 to that in 2009?
Provide a succinct answer. 1.36. What is the ratio of the Unemployed and educated labor force (% of population) of Netherlands in 2006 to that in 2009?
Offer a very short reply. 1.01. What is the ratio of the Unemployed and educated labor force (% of population) of Portugal in 2006 to that in 2009?
Keep it short and to the point. 0.98. What is the ratio of the Unemployed and educated labor force (% of population) of Georgia in 2006 to that in 2010?
Provide a short and direct response. 1.13. What is the ratio of the Unemployed and educated labor force (% of population) of Luxembourg in 2006 to that in 2010?
Make the answer very short. 1.52. What is the ratio of the Unemployed and educated labor force (% of population) in Portugal in 2006 to that in 2010?
Offer a terse response. 1.02. What is the ratio of the Unemployed and educated labor force (% of population) of Georgia in 2007 to that in 2008?
Provide a short and direct response. 1.11. What is the ratio of the Unemployed and educated labor force (% of population) of Luxembourg in 2007 to that in 2008?
Make the answer very short. 1.06. What is the ratio of the Unemployed and educated labor force (% of population) in Netherlands in 2007 to that in 2008?
Offer a terse response. 1. What is the ratio of the Unemployed and educated labor force (% of population) of Portugal in 2007 to that in 2008?
Your response must be concise. 1.01. What is the ratio of the Unemployed and educated labor force (% of population) in Georgia in 2007 to that in 2009?
Provide a succinct answer. 1.24. What is the ratio of the Unemployed and educated labor force (% of population) in Luxembourg in 2007 to that in 2009?
Offer a very short reply. 1.4. What is the ratio of the Unemployed and educated labor force (% of population) in Netherlands in 2007 to that in 2009?
Offer a very short reply. 1.05. What is the ratio of the Unemployed and educated labor force (% of population) in Portugal in 2007 to that in 2009?
Keep it short and to the point. 0.98. What is the ratio of the Unemployed and educated labor force (% of population) of Georgia in 2007 to that in 2010?
Offer a very short reply. 1.13. What is the ratio of the Unemployed and educated labor force (% of population) of Luxembourg in 2007 to that in 2010?
Your response must be concise. 1.57. What is the ratio of the Unemployed and educated labor force (% of population) of Netherlands in 2007 to that in 2010?
Provide a short and direct response. 1.01. What is the ratio of the Unemployed and educated labor force (% of population) in Portugal in 2007 to that in 2010?
Give a very brief answer. 1.02. What is the ratio of the Unemployed and educated labor force (% of population) in Georgia in 2008 to that in 2009?
Keep it short and to the point. 1.12. What is the ratio of the Unemployed and educated labor force (% of population) in Luxembourg in 2008 to that in 2009?
Make the answer very short. 1.32. What is the ratio of the Unemployed and educated labor force (% of population) in Netherlands in 2008 to that in 2009?
Your response must be concise. 1.05. What is the ratio of the Unemployed and educated labor force (% of population) in Portugal in 2008 to that in 2009?
Provide a short and direct response. 0.97. What is the ratio of the Unemployed and educated labor force (% of population) of Georgia in 2008 to that in 2010?
Offer a terse response. 1.02. What is the ratio of the Unemployed and educated labor force (% of population) in Luxembourg in 2008 to that in 2010?
Your answer should be very brief. 1.49. What is the ratio of the Unemployed and educated labor force (% of population) of Netherlands in 2008 to that in 2010?
Keep it short and to the point. 1.01. What is the ratio of the Unemployed and educated labor force (% of population) in Portugal in 2008 to that in 2010?
Provide a succinct answer. 1.01. What is the ratio of the Unemployed and educated labor force (% of population) of Georgia in 2009 to that in 2010?
Your answer should be very brief. 0.91. What is the ratio of the Unemployed and educated labor force (% of population) of Luxembourg in 2009 to that in 2010?
Your answer should be compact. 1.12. What is the ratio of the Unemployed and educated labor force (% of population) of Netherlands in 2009 to that in 2010?
Your answer should be very brief. 0.97. What is the ratio of the Unemployed and educated labor force (% of population) of Portugal in 2009 to that in 2010?
Ensure brevity in your answer.  1.04. What is the difference between the highest and the second highest Unemployed and educated labor force (% of population) of Netherlands?
Ensure brevity in your answer.  0. What is the difference between the highest and the lowest Unemployed and educated labor force (% of population) in Georgia?
Offer a very short reply. 1. What is the difference between the highest and the lowest Unemployed and educated labor force (% of population) in Netherlands?
Offer a terse response. 1.8. What is the difference between the highest and the lowest Unemployed and educated labor force (% of population) in Portugal?
Make the answer very short. 3.3. 